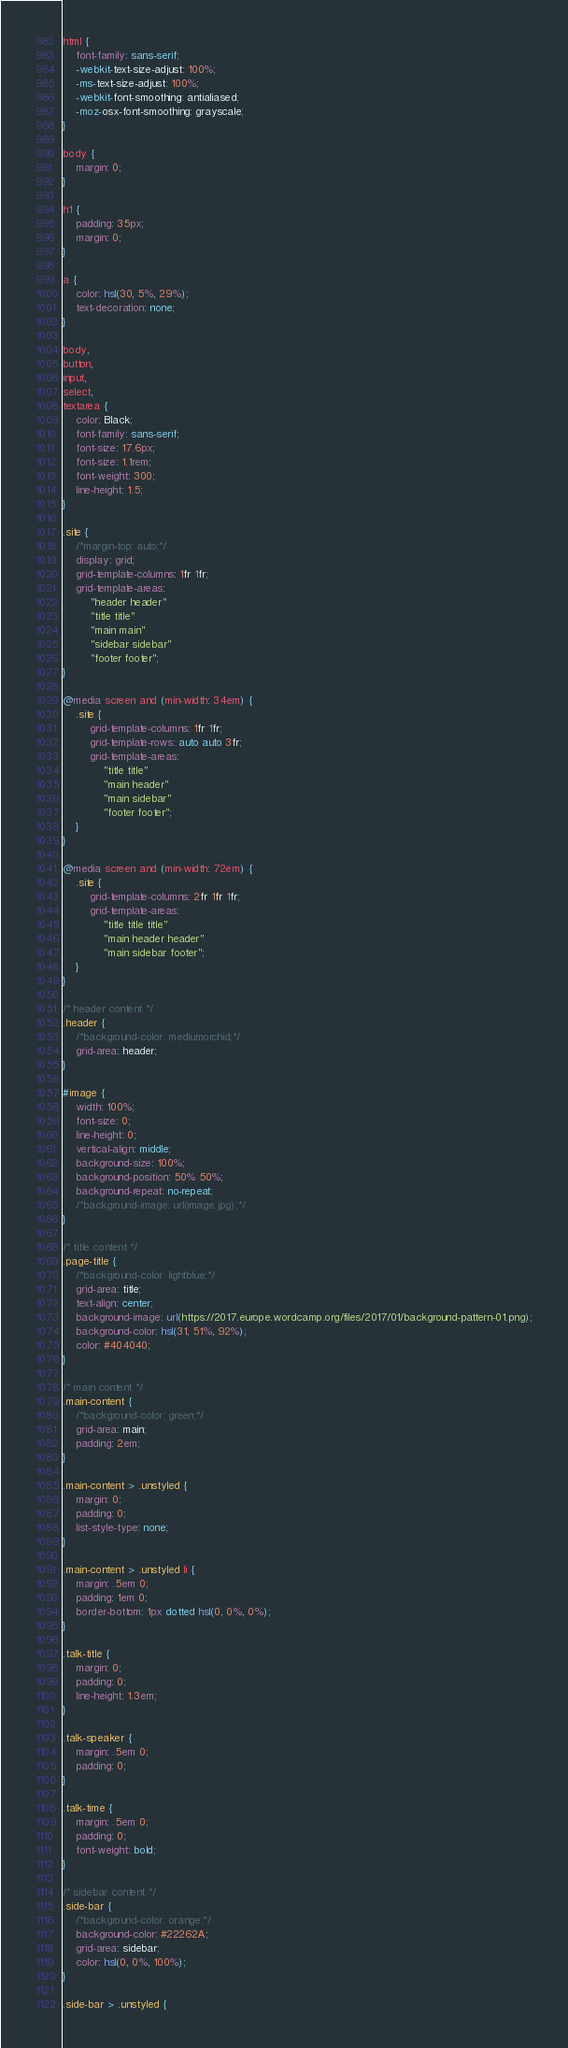Convert code to text. <code><loc_0><loc_0><loc_500><loc_500><_CSS_>html {
	font-family: sans-serif;
	-webkit-text-size-adjust: 100%;
	-ms-text-size-adjust: 100%;
	-webkit-font-smoothing: antialiased;
	-moz-osx-font-smoothing: grayscale;
}

body {
	margin: 0;
}

h1 {
    padding: 35px;
	margin: 0;
}

a {
    color: hsl(30, 5%, 29%);
    text-decoration: none;
}

body,
button,
input,
select,
textarea {
	color: Black;
	font-family: sans-serif;
	font-size: 17.6px;
	font-size: 1.1rem;
	font-weight: 300;
	line-height: 1.5;
}

.site {
	/*margin-top: auto;*/
    display: grid;
    grid-template-columns: 1fr 1fr;
    grid-template-areas:
        "header header"
        "title title"
        "main main"
        "sidebar sidebar"
        "footer footer";
}

@media screen and (min-width: 34em) {
    .site {
        grid-template-columns: 1fr 1fr;
        grid-template-rows: auto auto 3fr;
        grid-template-areas:
            "title title"
            "main header"
			"main sidebar"
            "footer footer";
    }
}

@media screen and (min-width: 72em) {
    .site {
        grid-template-columns: 2fr 1fr 1fr;
        grid-template-areas:
            "title title title"
            "main header header"
            "main sidebar footer";
    }
}

/* header content */
.header {
	/*background-color: mediumorchid;*/
    grid-area: header;
}

#image {
    width: 100%;
    font-size: 0;
    line-height: 0;
    vertical-align: middle;
    background-size: 100%;
    background-position: 50% 50%;
    background-repeat: no-repeat;
    /*background-image: url(image.jpg);*/
}

/* title content */
.page-title {
    /*background-color: lightblue;*/
    grid-area: title;
	text-align: center;
	background-image: url(https://2017.europe.wordcamp.org/files/2017/01/background-pattern-01.png);
	background-color: hsl(31, 51%, 92%);
	color: #404040;
}

/* main content */
.main-content {
    /*background-color: green;*/
    grid-area: main;
	padding: 2em;
}

.main-content > .unstyled {
	margin: 0;
	padding: 0;
	list-style-type: none;
}

.main-content > .unstyled li {
	margin: .5em 0;
    padding: 1em 0;
	border-bottom: 1px dotted hsl(0, 0%, 0%);
}

.talk-title {
    margin: 0;
    padding: 0;
    line-height: 1.3em;
}

.talk-speaker {
    margin: .5em 0;
    padding: 0;
}

.talk-time {
    margin: .5em 0;
    padding: 0;
    font-weight: bold;
}

/* sidebar content */
.side-bar {
    /*background-color: orange;*/
	background-color: #22262A;
    grid-area: sidebar;
	color: hsl(0, 0%, 100%);
}

.side-bar > .unstyled {</code> 